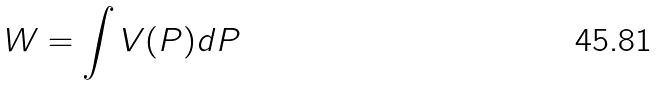Convert formula to latex. <formula><loc_0><loc_0><loc_500><loc_500>W = \int V ( P ) d P</formula> 